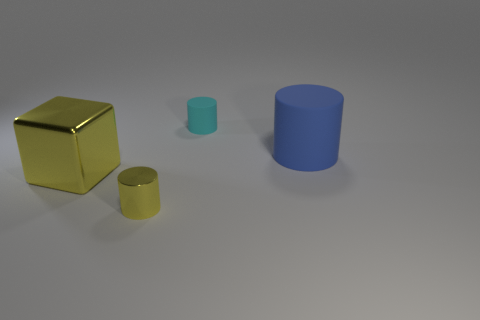How do the objects in the image relate to each other? The objects are positioned apart from each other on a flat surface, varying in color and size. The arrangement has a balanced composition, providing a sense of order and space. 